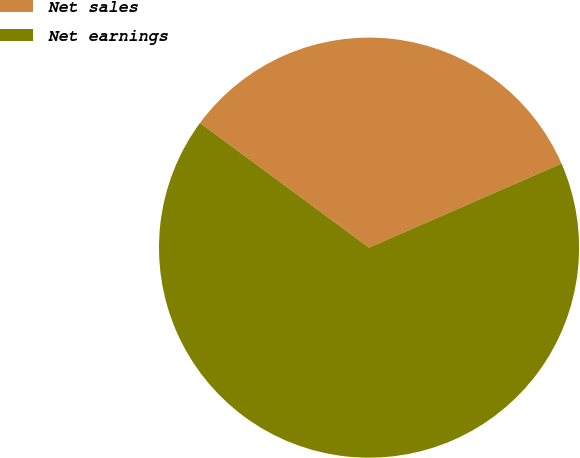Convert chart. <chart><loc_0><loc_0><loc_500><loc_500><pie_chart><fcel>Net sales<fcel>Net earnings<nl><fcel>33.33%<fcel>66.67%<nl></chart> 